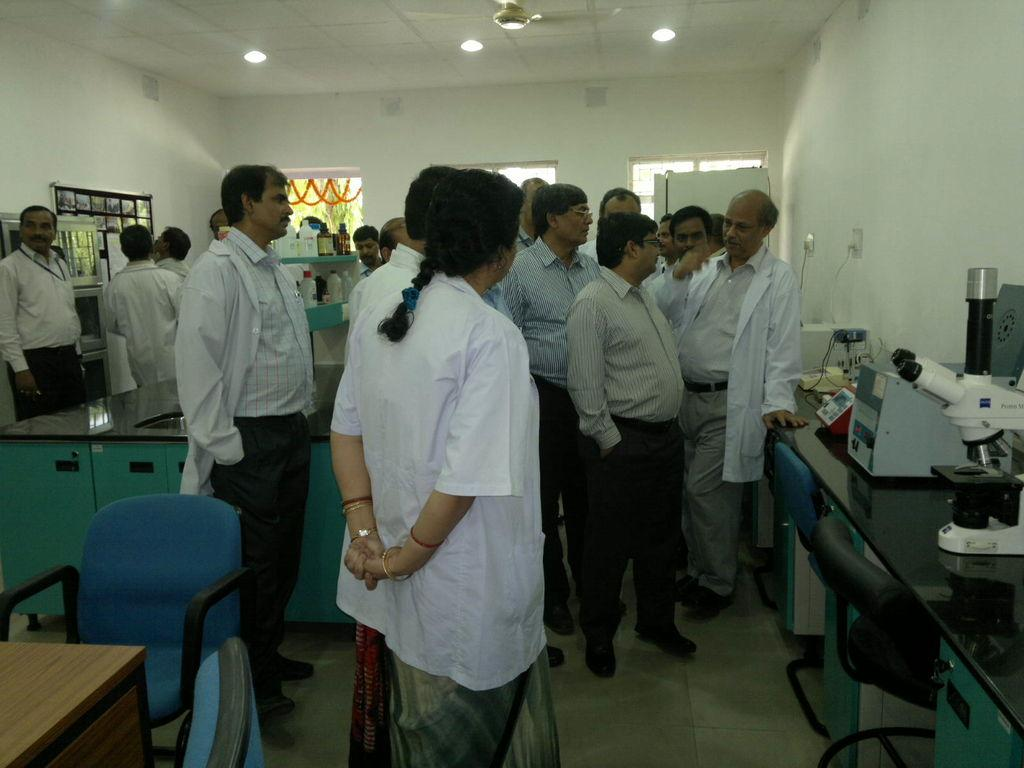How many people are visible in the image? There are many people standing in the image. What are the people wearing? The people are wearing aprons. What can be seen on a table in the image? There is some equipment on a table in the image. What is visible in the background of the image? There is a wall in the background of the image. What type of brass instrument is being played by the people in the image? There is no brass instrument visible in the image; the people are wearing aprons and there is equipment on a table, but no musical instruments are present. 